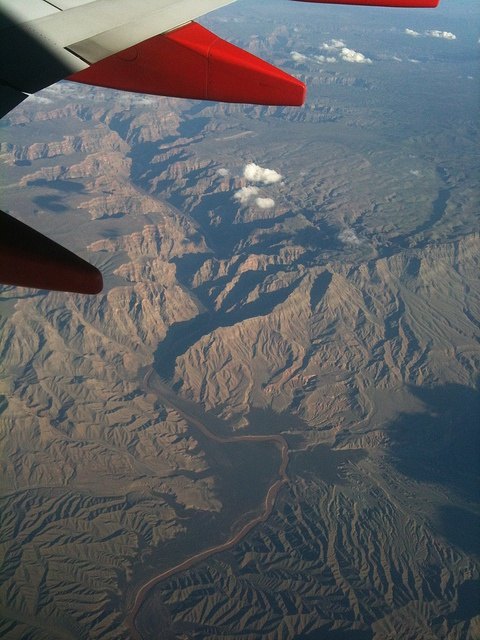Describe the objects in this image and their specific colors. I can see a airplane in darkgray, black, maroon, and lightgray tones in this image. 